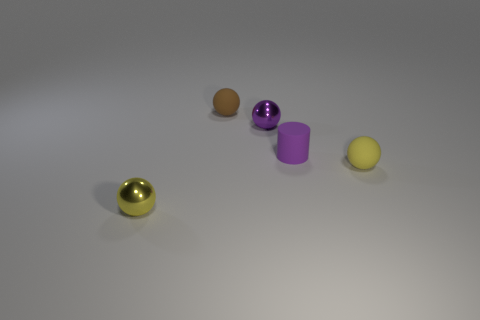Are there any other things that have the same color as the small cylinder?
Your answer should be very brief. Yes. What number of objects are either small objects that are in front of the small brown sphere or shiny balls behind the yellow matte ball?
Give a very brief answer. 4. What is the shape of the small thing that is both behind the small cylinder and in front of the brown ball?
Offer a terse response. Sphere. How many tiny yellow metallic things are behind the rubber object in front of the purple matte thing?
Give a very brief answer. 0. Are there any other things that are the same material as the tiny purple ball?
Provide a succinct answer. Yes. What number of things are either spheres behind the purple shiny object or small purple things?
Provide a short and direct response. 3. There is a metallic object that is on the left side of the small brown object; what is its size?
Your answer should be compact. Small. What is the purple cylinder made of?
Your answer should be compact. Rubber. What is the shape of the yellow object that is to the right of the small thing behind the tiny purple metallic ball?
Give a very brief answer. Sphere. How many other things are there of the same shape as the brown object?
Ensure brevity in your answer.  3. 